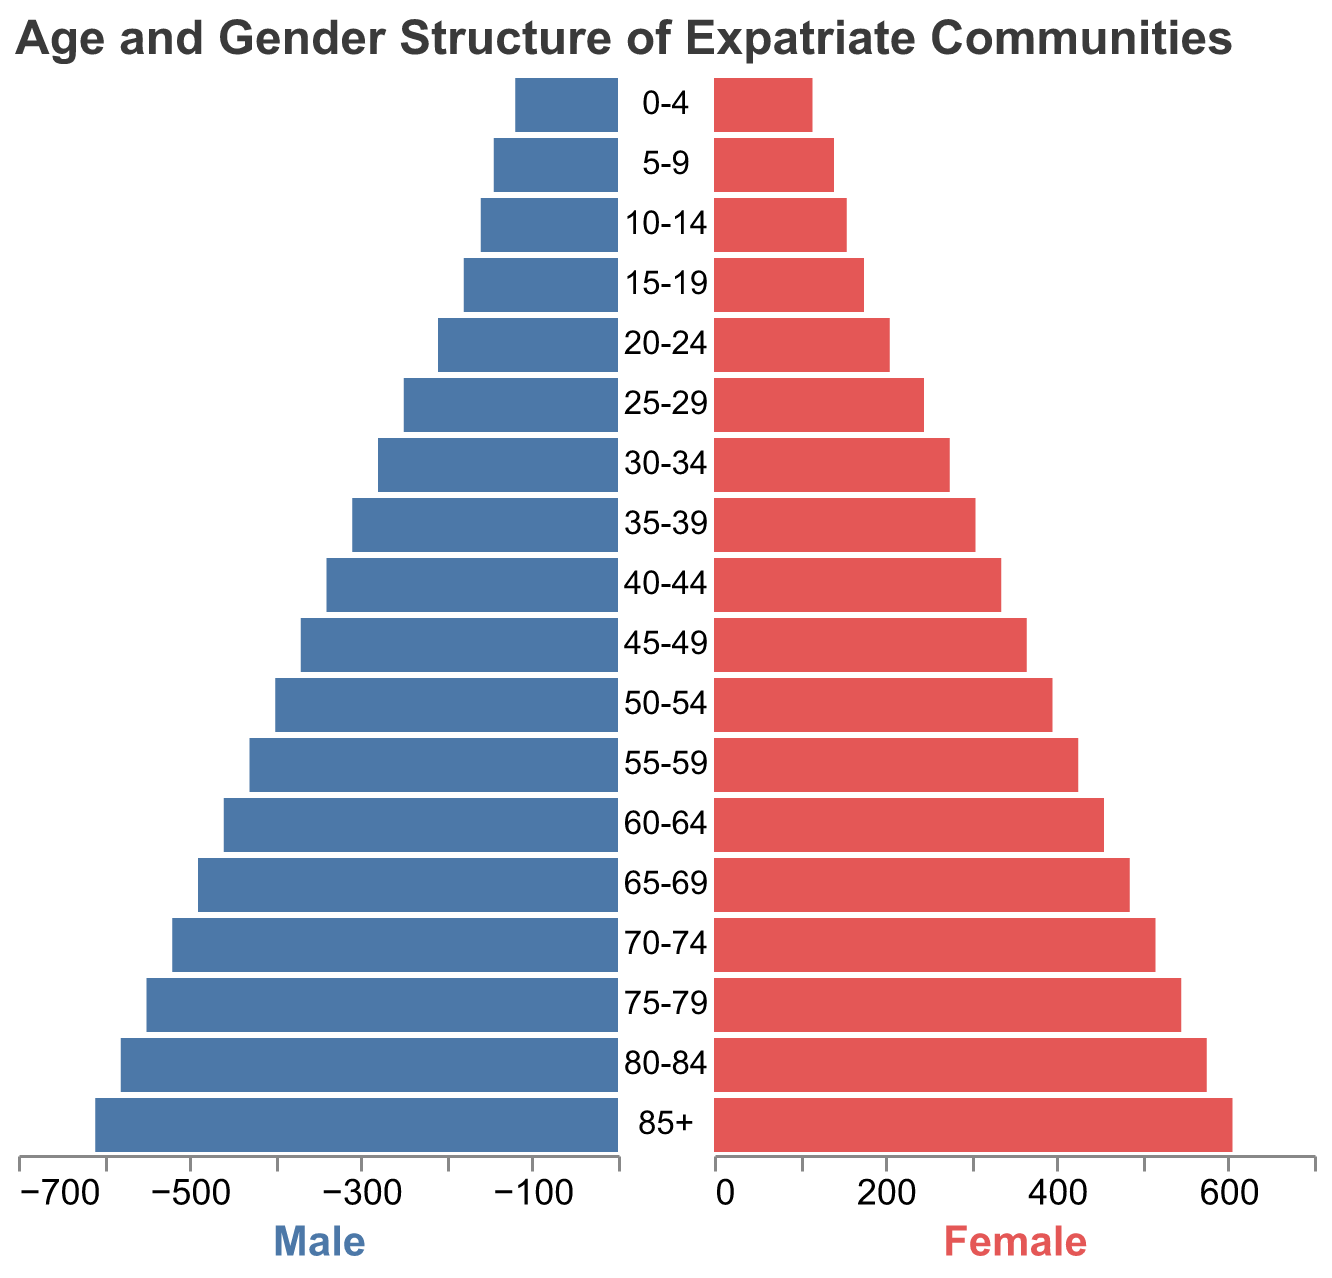What is the title of the figure? The title is displayed at the top of the figure. It reads "Age and Gender Structure of Expatriate Communities".
Answer: Age and Gender Structure of Expatriate Communities Which age group has the highest number of males? By looking at the length of the bars on the left side (male), the age group "85+" has the longest bar representing 610 males.
Answer: 85+ How does the number of females in the 70-74 age group compare to those in the 30-34 age group? Check the length of the female bars for both age groups. The 70-74 group has 515 females, while the 30-34 group has 275 females.
Answer: More in 70-74 What is the total number of expatriates (both male and female) in the 50-54 age group? Add the number of males and females in the 50-54 age group: 400 (males) + 395 (females).
Answer: 795 Which gender has more individuals in the 25-29 age group? Compare the bars for the 25-29 age group. Males have 250 and females have 245.
Answer: Males In which age group do males and females have the smallest difference in numbers? Calculate the absolute difference between males and females for each age group and identify the smallest difference, which is in the 5-9 age group: abs(145 - 140) = 5.
Answer: 5-9 What is the average number of females across all age groups? Sum the number of females across all age groups and divide by the number of age groups. (115 + 140 + 155 + 175 + 205 + 245 + 275 + 305 + 335 + 365 + 395 + 425 + 455 + 485 + 515 + 545 + 575 + 605) / 18 = 365.28
Answer: 365.28 Which age group has the largest population overall? Add the numbers for both genders for each age group and compare the totals. The age group 85+ has the largest population: 610 (males) + 605 (females) = 1215.
Answer: 85+ Is the male population larger than the female population in most age groups? Compare the number of males versus females across all age groups. Males outnumber females in all provided age groups.
Answer: Yes 